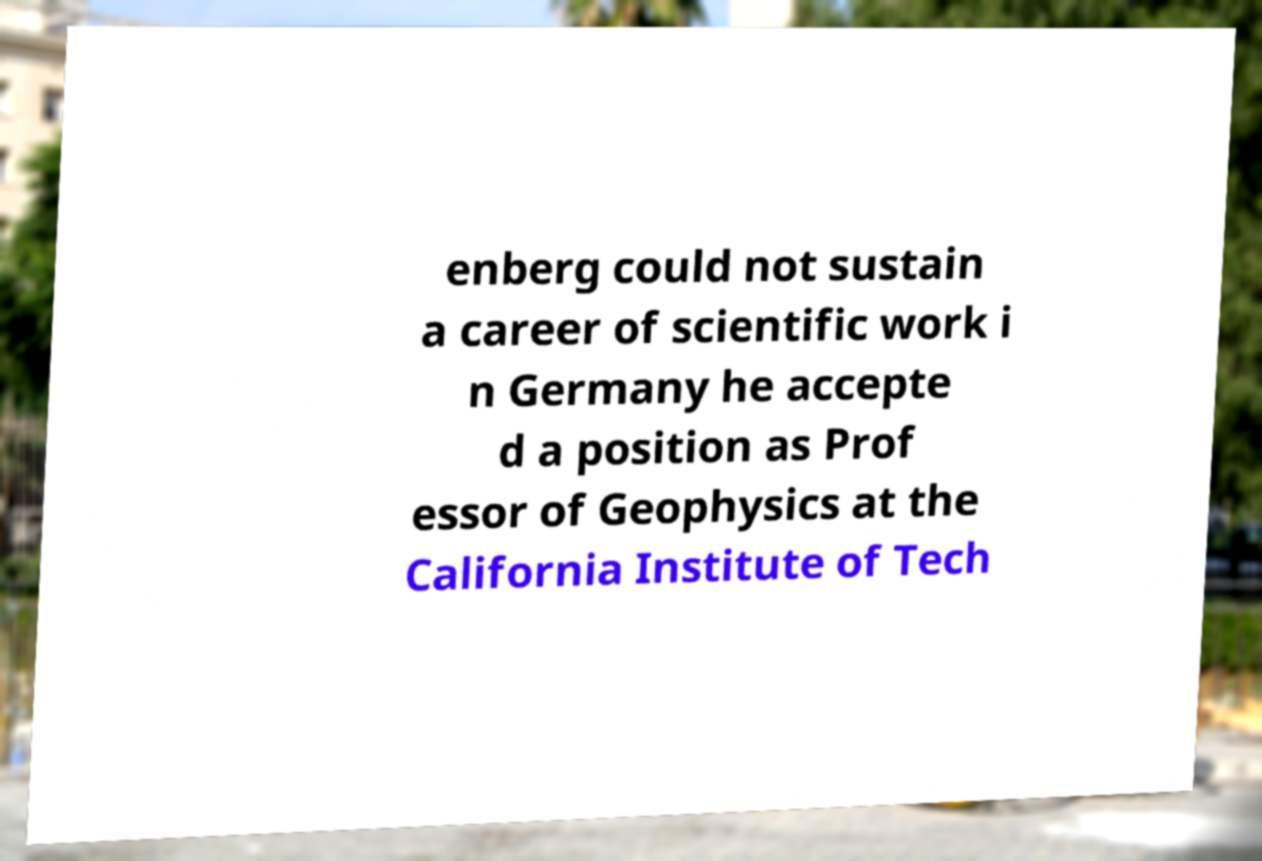Please read and relay the text visible in this image. What does it say? enberg could not sustain a career of scientific work i n Germany he accepte d a position as Prof essor of Geophysics at the California Institute of Tech 